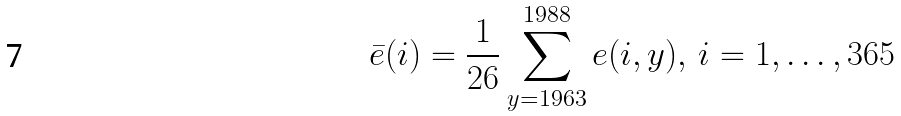Convert formula to latex. <formula><loc_0><loc_0><loc_500><loc_500>\bar { e } ( i ) = \frac { 1 } { 2 6 } \sum _ { y = 1 9 6 3 } ^ { 1 9 8 8 } e ( i , y ) , \, i = 1 , \dots , 3 6 5</formula> 